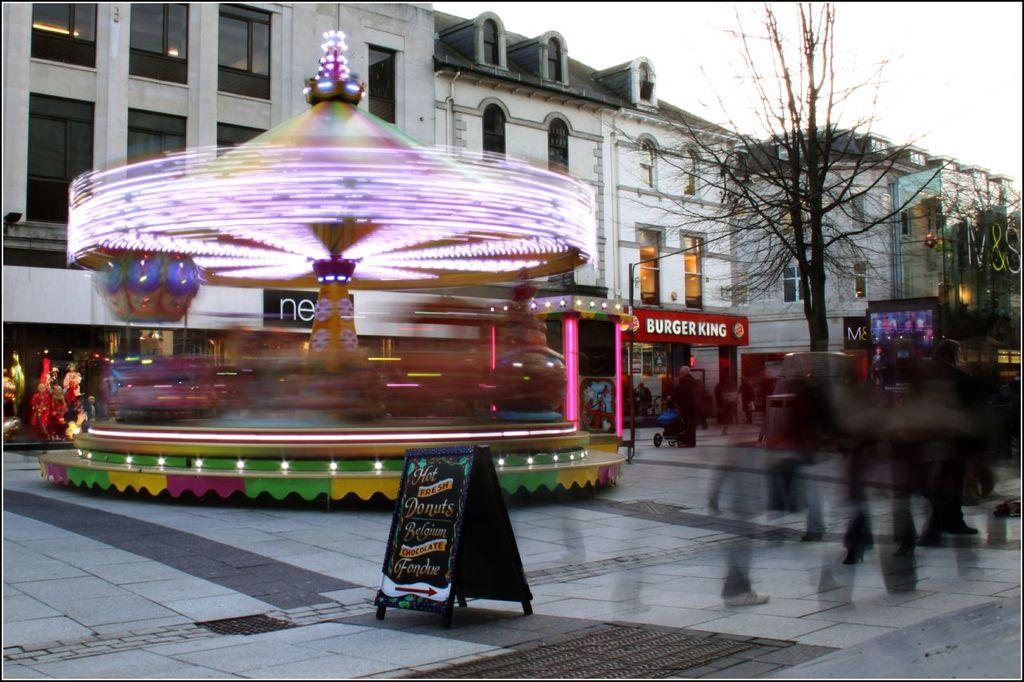<image>
Give a short and clear explanation of the subsequent image. The store in red in the background is Burger King 